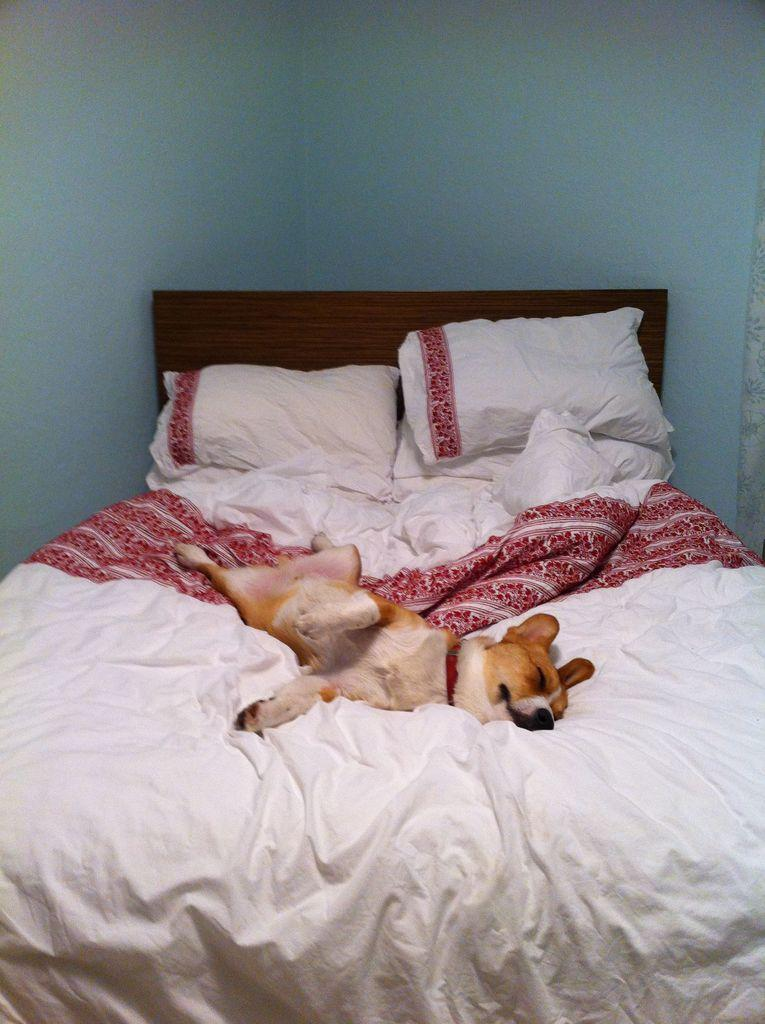What piece of furniture is present in the image? There is a bed in the image. What color is the bed sheet on the bed? The bed sheet on the bed is white. What else is white on the bed? The pillows on the bed are also white. What is the dog on the bed doing? The dog on the bed is sleeping. What color is the wall in the background of the image? The wall in the background of the image is blue. How does the dog maintain its balance on the bed while attacking the lettuce? There is no lettuce present in the image, and the dog is sleeping, not attacking anything. 